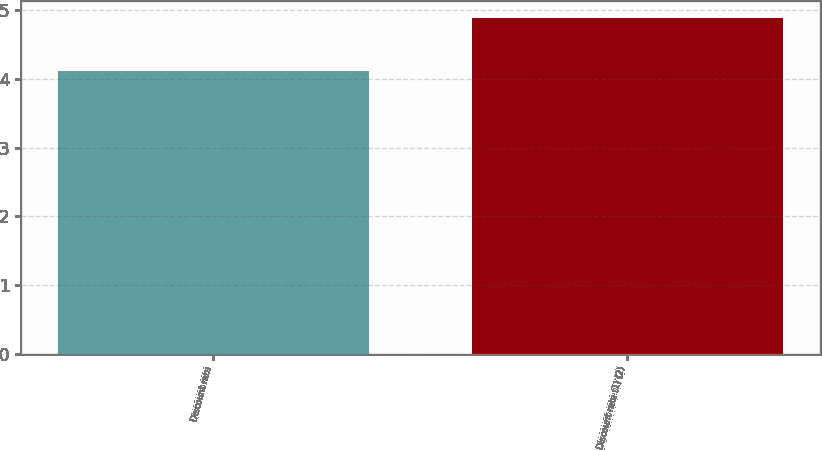Convert chart to OTSL. <chart><loc_0><loc_0><loc_500><loc_500><bar_chart><fcel>Discount rate<fcel>Discount rate (1) (2)<nl><fcel>4.12<fcel>4.89<nl></chart> 